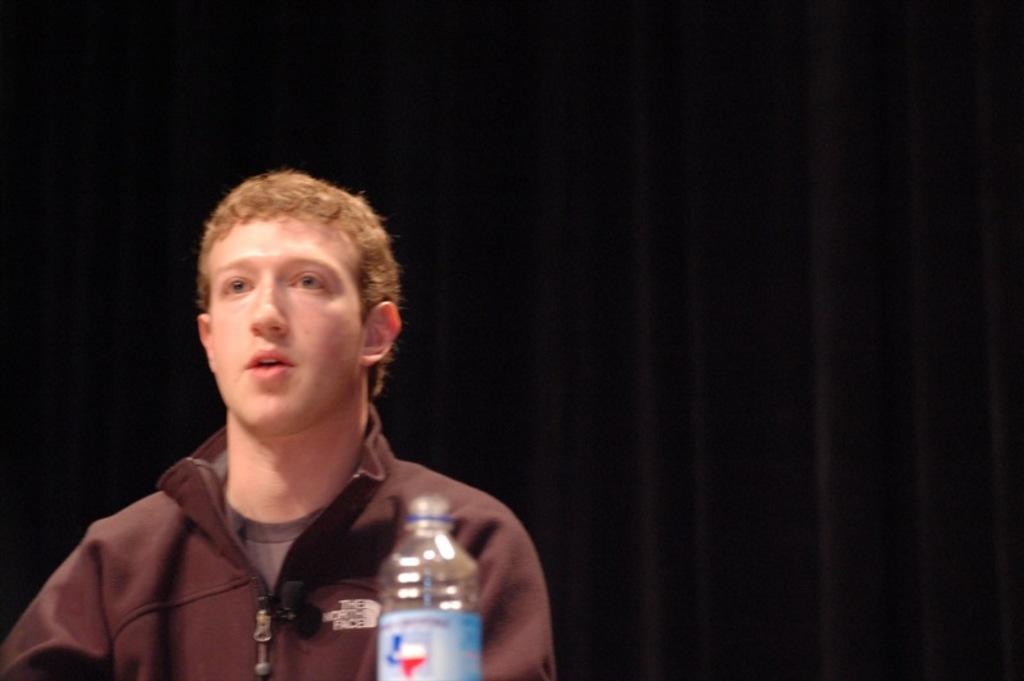Could you give a brief overview of what you see in this image? Here we can see a man and a bottle in front of him 